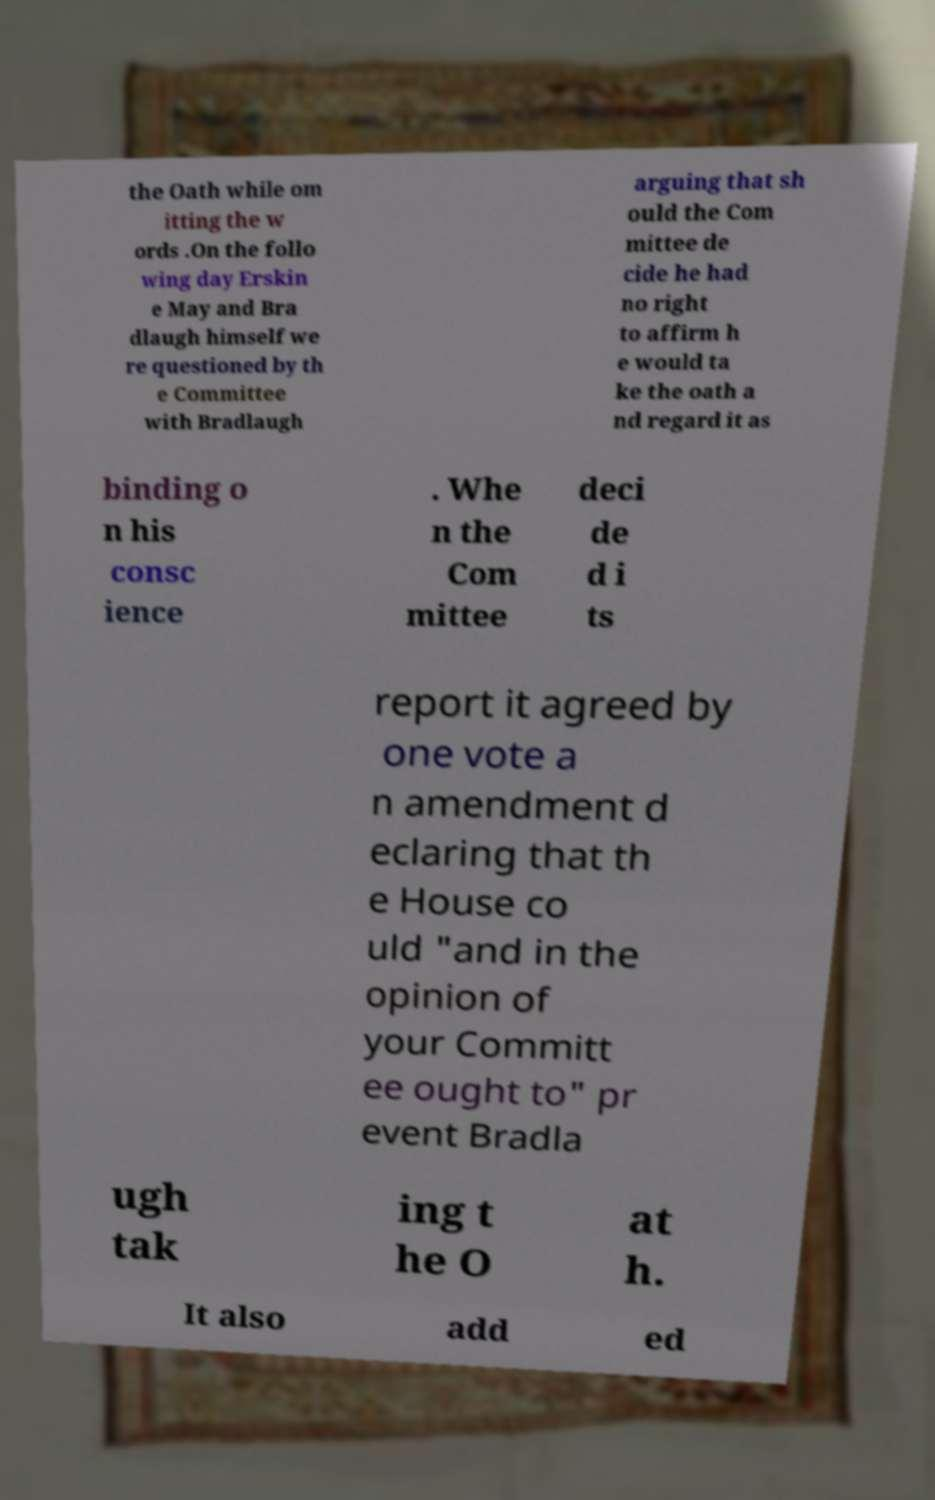What messages or text are displayed in this image? I need them in a readable, typed format. the Oath while om itting the w ords .On the follo wing day Erskin e May and Bra dlaugh himself we re questioned by th e Committee with Bradlaugh arguing that sh ould the Com mittee de cide he had no right to affirm h e would ta ke the oath a nd regard it as binding o n his consc ience . Whe n the Com mittee deci de d i ts report it agreed by one vote a n amendment d eclaring that th e House co uld "and in the opinion of your Committ ee ought to" pr event Bradla ugh tak ing t he O at h. It also add ed 